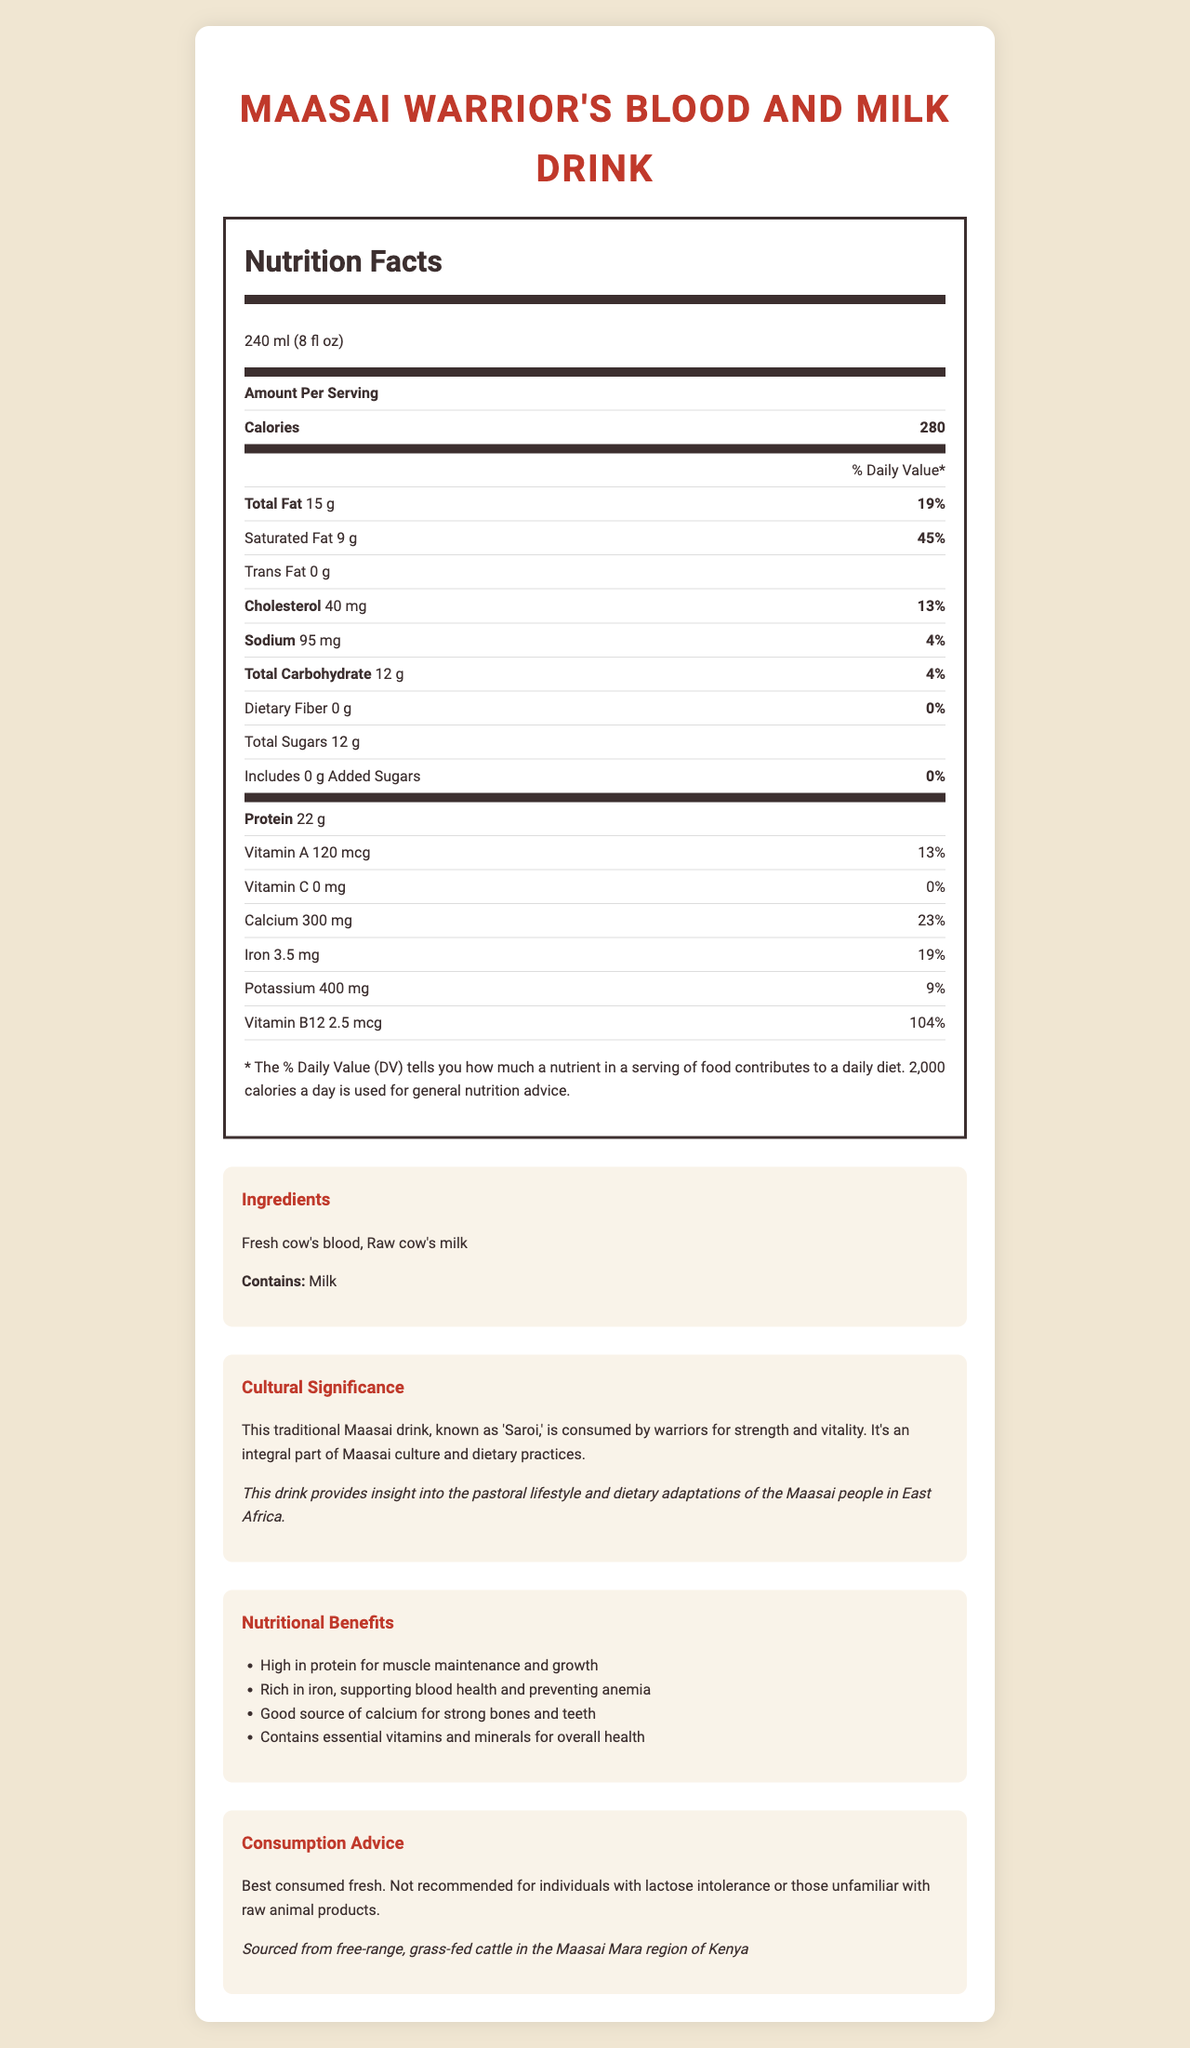what is the serving size for the Maasai Warrior's Blood and Milk Drink? The serving size is explicitly stated as 240 ml (8 fl oz) in the document.
Answer: 240 ml (8 fl oz) how many calories are there per serving? The document specifies that there are 280 calories per serving.
Answer: 280 what are the two main ingredients in the Maasai Warrior's Blood and Milk Drink? The ingredients listed in the document are fresh cow's blood and raw cow's milk.
Answer: Fresh cow's blood, Raw cow's milk how much protein does one serving of the drink contain? The document states that one serving contains 22 grams of protein.
Answer: 22 g what percentage of Daily Value of Vitamin B12 does one serving provide? According to the document, one serving provides 104% of the Daily Value of Vitamin B12.
Answer: 104% what is the traditional Maasai name for this drink? A. Kuni B. Saroi C. Enkiteng D. Nyama Choma The document mentions that the traditional Maasai name for the drink is "Saroi."
Answer: B which of the following nutrients is NOT present in the Maasai Warrior's Blood and Milk Drink? 1. Iron, 2. Vitamin C, 3. Fiber, 4. Potassium Fiber is present at 0 g in the drink, as mentioned in the document.
Answer: 3. Fiber is this drink high in saturated fat? The document indicates that one serving contains 9 g of saturated fat, which is 45% of the Daily Value, making it high in saturated fat.
Answer: Yes can someone with lactose intolerance consume this drink? The document advises that it is not recommended for individuals with lactose intolerance due to the presence of milk.
Answer: No summarize the main idea of the document. The document covers the nutritional facts, ingredients, cultural significance, nutritional benefits, consumption advice, and sustainability of the drink, emphasizing its importance in Maasai culture and dietary practices.
Answer: The document provides detailed nutritional information for the Maasai Warrior's Blood and Milk Drink, a traditional beverage made from fresh cow's blood and raw milk, highlighting its high protein, iron, and calcium content, cultural significance for the Maasai people, and its sustainability sourced from free-range cattle in Kenya. It also advises caution for lactose-intolerant individuals. how long is the document? The length of the document is not specified or measurable based on the visual information provided in the document.
Answer: Cannot be determined what is the main allergen in the drink? The document lists milk as the drink's main allergen.
Answer: Milk what type of lifestyle and dietary practices does this drink provide insight into? The document mentions that this drink provides insight into the pastoral lifestyle and dietary adaptations of the Maasai people in East Africa.
Answer: Pastoral lifestyle and dietary adaptations of the Maasai people how much calcium does one serving provide? According to the document, one serving provides 300 mg of calcium.
Answer: 300 mg what is the protein's primary benefit mentioned in the document? A. Energy B. Muscle maintenance and growth C. Immune support D. Hydration The document states that the high protein content is beneficial for muscle maintenance and growth.
Answer: B 